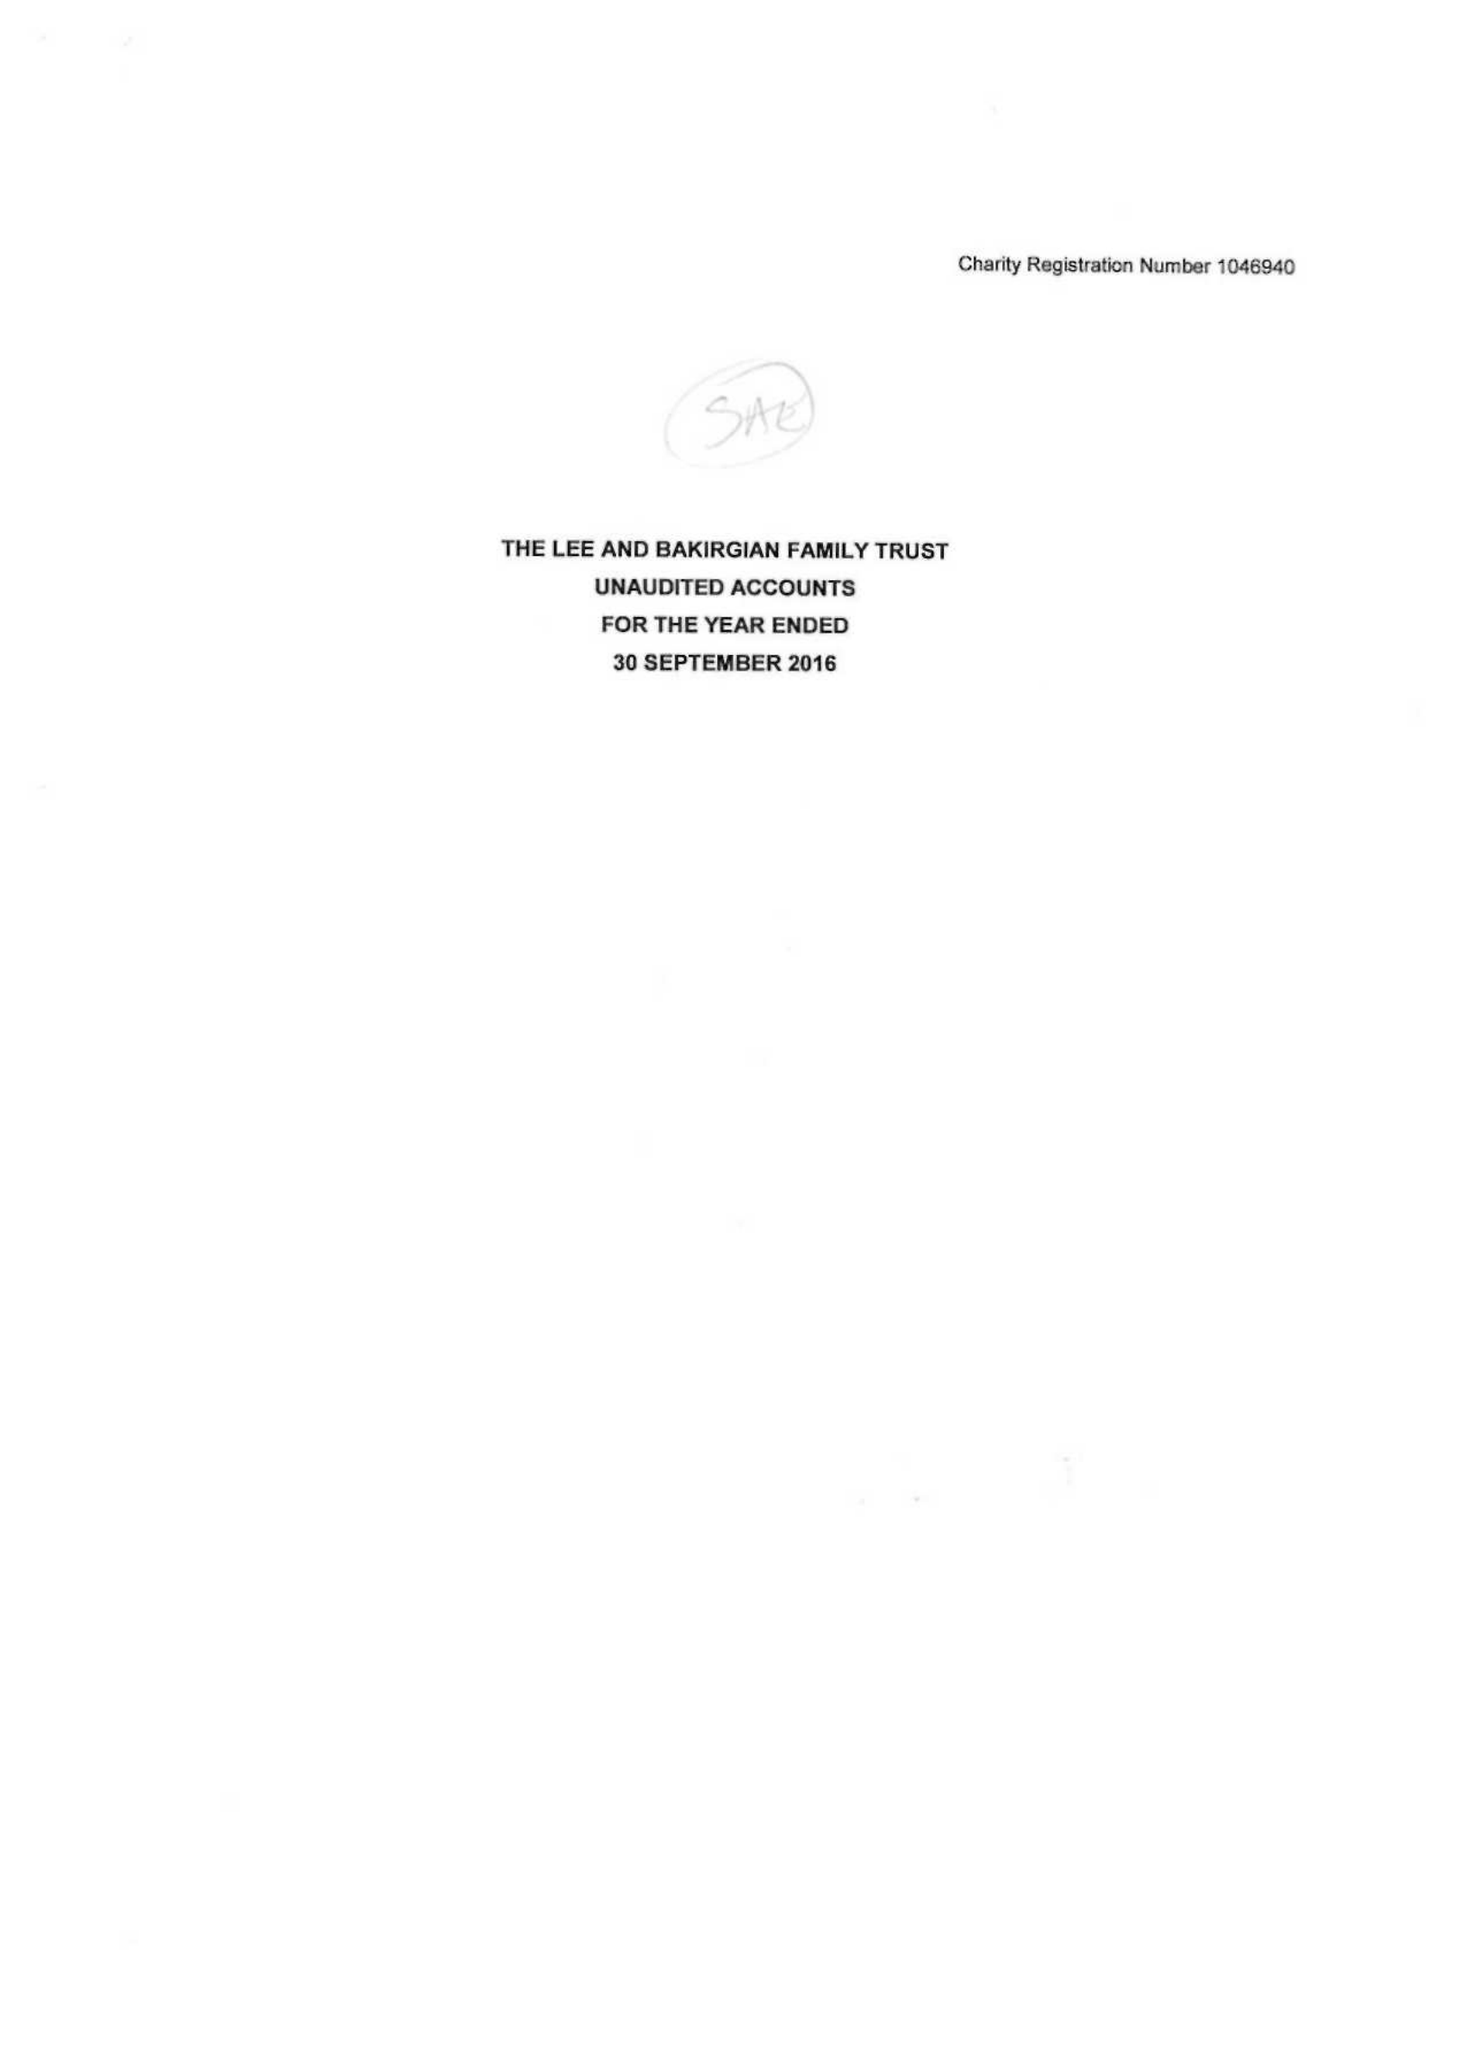What is the value for the address__postcode?
Answer the question using a single word or phrase. WA3 3JD 